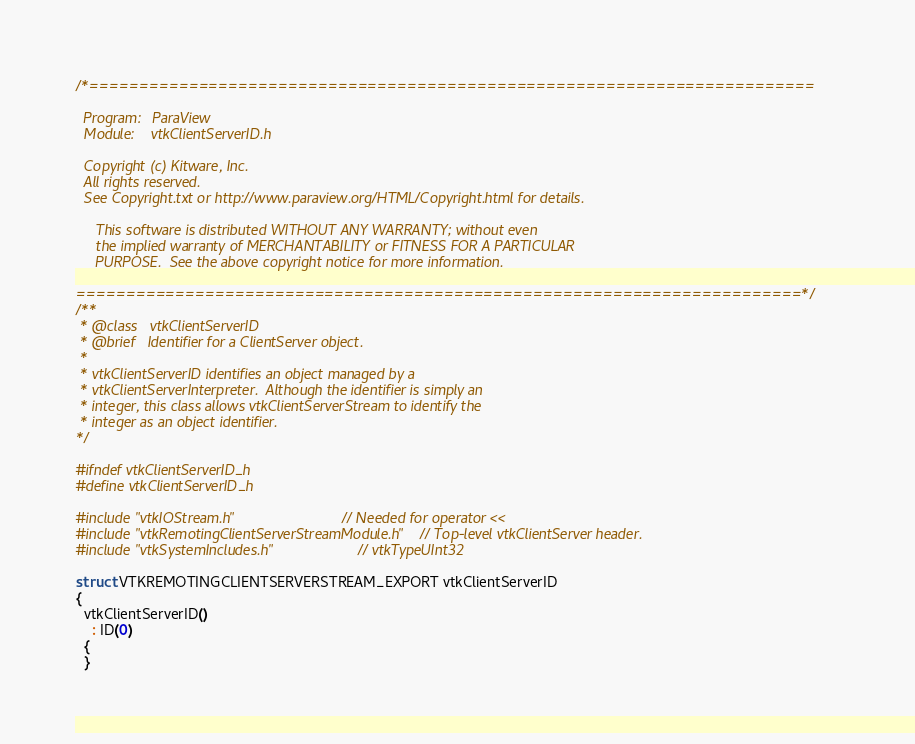<code> <loc_0><loc_0><loc_500><loc_500><_C_>/*=========================================================================

  Program:   ParaView
  Module:    vtkClientServerID.h

  Copyright (c) Kitware, Inc.
  All rights reserved.
  See Copyright.txt or http://www.paraview.org/HTML/Copyright.html for details.

     This software is distributed WITHOUT ANY WARRANTY; without even
     the implied warranty of MERCHANTABILITY or FITNESS FOR A PARTICULAR
     PURPOSE.  See the above copyright notice for more information.

=========================================================================*/
/**
 * @class   vtkClientServerID
 * @brief   Identifier for a ClientServer object.
 *
 * vtkClientServerID identifies an object managed by a
 * vtkClientServerInterpreter.  Although the identifier is simply an
 * integer, this class allows vtkClientServerStream to identify the
 * integer as an object identifier.
*/

#ifndef vtkClientServerID_h
#define vtkClientServerID_h

#include "vtkIOStream.h"                         // Needed for operator <<
#include "vtkRemotingClientServerStreamModule.h" // Top-level vtkClientServer header.
#include "vtkSystemIncludes.h"                   // vtkTypeUInt32

struct VTKREMOTINGCLIENTSERVERSTREAM_EXPORT vtkClientServerID
{
  vtkClientServerID()
    : ID(0)
  {
  }</code> 